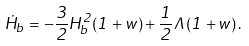<formula> <loc_0><loc_0><loc_500><loc_500>\dot { H } _ { b } = - \frac { 3 } { 2 } H _ { b } ^ { 2 } ( 1 + w ) + \frac { 1 } { 2 } \Lambda ( 1 + w ) \, .</formula> 